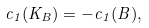Convert formula to latex. <formula><loc_0><loc_0><loc_500><loc_500>c _ { 1 } ( K _ { B } ) = - c _ { 1 } ( B ) ,</formula> 